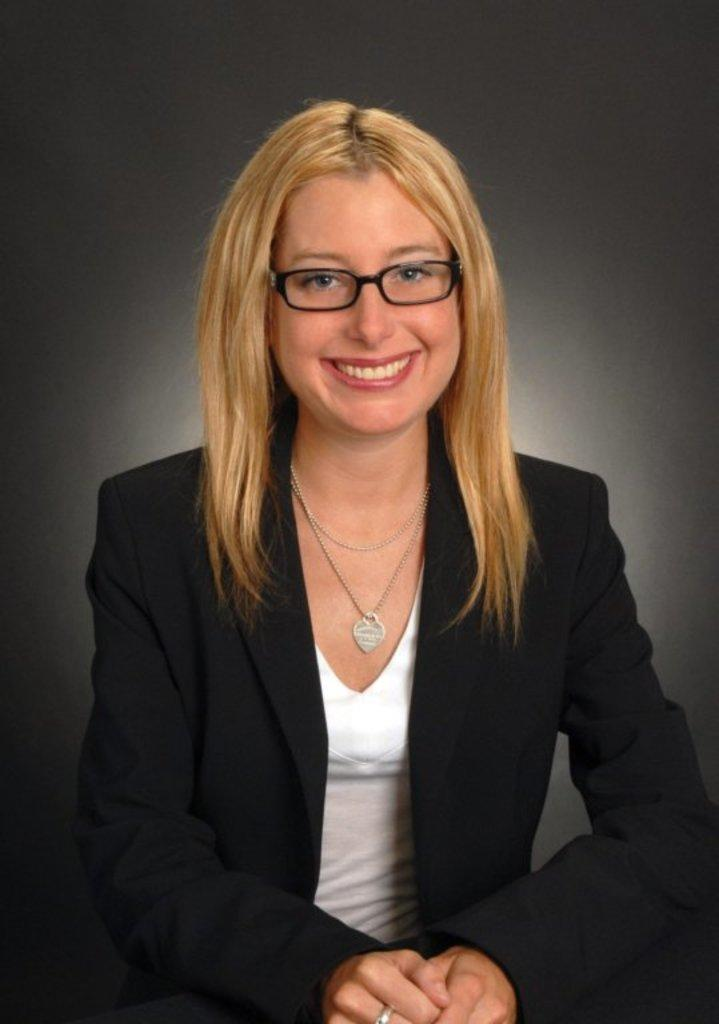What is the main subject of the image? The main subject of the image is a woman. What is the woman wearing in the image? The woman is wearing a black coat in the image. Are there any accessories visible on the woman? Yes, the woman is wearing spectacles in the image. What is the woman's facial expression in the image? The woman is smiling in the image. Can you tell me how many turkeys are in the image? There are no turkeys present in the image; it features a woman wearing a black coat and spectacles while smiling. Is the woman in the image asking for help? There is no indication in the image that the woman is asking for help; she is simply smiling. 